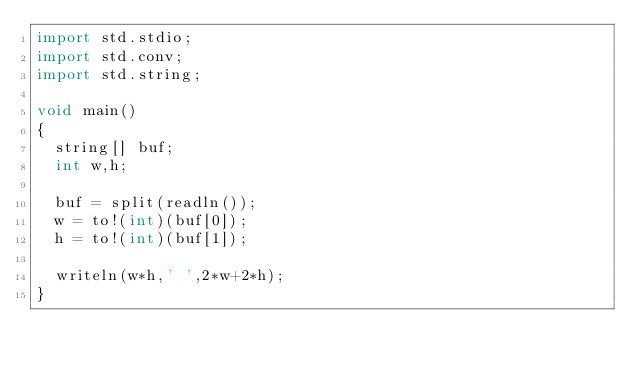Convert code to text. <code><loc_0><loc_0><loc_500><loc_500><_D_>import std.stdio;
import std.conv;
import std.string;

void main()
{
  string[] buf;
  int w,h;

  buf = split(readln());
  w = to!(int)(buf[0]);
  h = to!(int)(buf[1]);

  writeln(w*h,' ',2*w+2*h);
}</code> 